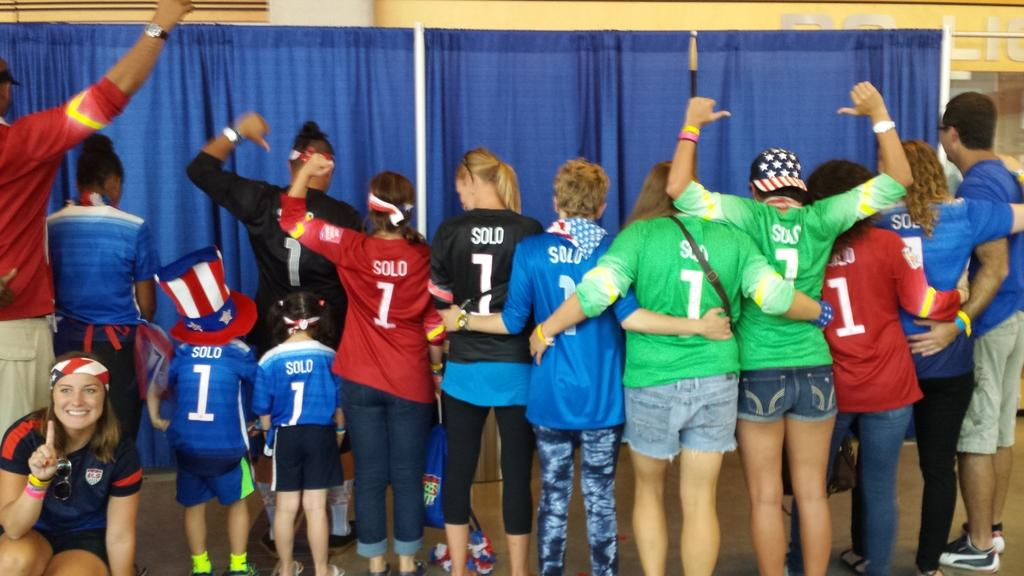<image>
Give a short and clear explanation of the subsequent image. A row of people, adults and children, male and female, are lined up facing back, all wearing jerseys with the number one on them. 